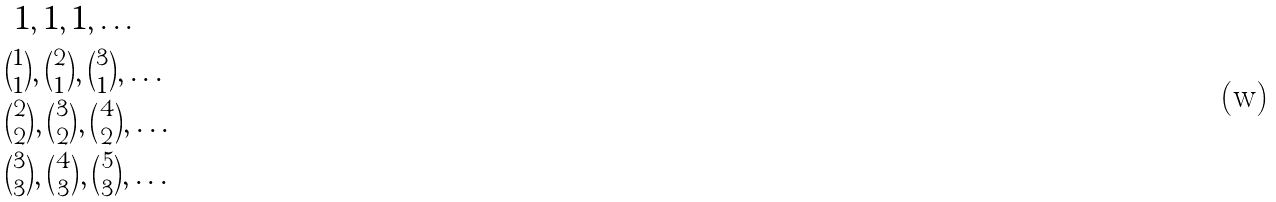<formula> <loc_0><loc_0><loc_500><loc_500>& \ 1 , 1 , 1 , \dots \\ & \tbinom { 1 } { 1 } , \tbinom { 2 } { 1 } , \tbinom { 3 } { 1 } , \dots \\ & \tbinom { 2 } { 2 } , \tbinom { 3 } { 2 } , \tbinom { 4 } { 2 } , \dots \\ & \tbinom { 3 } { 3 } , \tbinom { 4 } { 3 } , \tbinom { 5 } { 3 } , \dots</formula> 